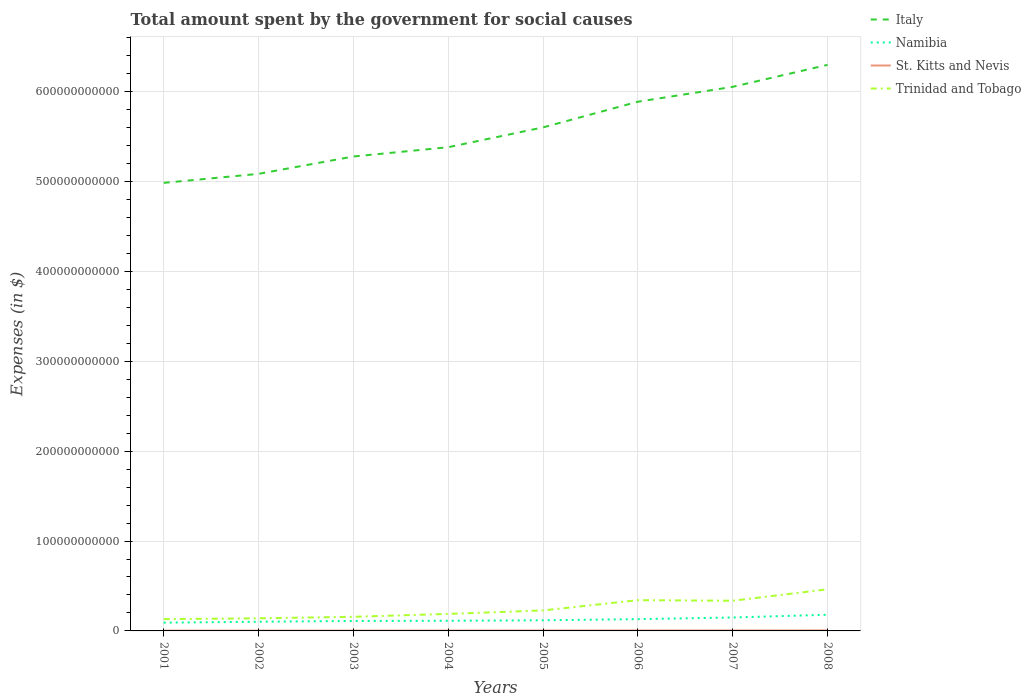How many different coloured lines are there?
Give a very brief answer. 4. Does the line corresponding to Trinidad and Tobago intersect with the line corresponding to St. Kitts and Nevis?
Provide a succinct answer. No. Across all years, what is the maximum amount spent for social causes by the government in St. Kitts and Nevis?
Keep it short and to the point. 3.07e+08. In which year was the amount spent for social causes by the government in Namibia maximum?
Make the answer very short. 2001. What is the total amount spent for social causes by the government in Trinidad and Tobago in the graph?
Offer a very short reply. -3.23e+1. What is the difference between the highest and the second highest amount spent for social causes by the government in St. Kitts and Nevis?
Ensure brevity in your answer.  2.29e+08. How many lines are there?
Your answer should be compact. 4. How many years are there in the graph?
Your response must be concise. 8. What is the difference between two consecutive major ticks on the Y-axis?
Offer a terse response. 1.00e+11. Does the graph contain any zero values?
Your response must be concise. No. What is the title of the graph?
Ensure brevity in your answer.  Total amount spent by the government for social causes. Does "Kiribati" appear as one of the legend labels in the graph?
Give a very brief answer. No. What is the label or title of the X-axis?
Your answer should be very brief. Years. What is the label or title of the Y-axis?
Make the answer very short. Expenses (in $). What is the Expenses (in $) of Italy in 2001?
Your answer should be compact. 4.99e+11. What is the Expenses (in $) of Namibia in 2001?
Your answer should be very brief. 9.20e+09. What is the Expenses (in $) of St. Kitts and Nevis in 2001?
Provide a short and direct response. 3.07e+08. What is the Expenses (in $) of Trinidad and Tobago in 2001?
Make the answer very short. 1.31e+1. What is the Expenses (in $) of Italy in 2002?
Your answer should be compact. 5.09e+11. What is the Expenses (in $) in Namibia in 2002?
Make the answer very short. 1.02e+1. What is the Expenses (in $) of St. Kitts and Nevis in 2002?
Provide a succinct answer. 3.24e+08. What is the Expenses (in $) in Trinidad and Tobago in 2002?
Give a very brief answer. 1.40e+1. What is the Expenses (in $) of Italy in 2003?
Make the answer very short. 5.28e+11. What is the Expenses (in $) of Namibia in 2003?
Offer a very short reply. 1.11e+1. What is the Expenses (in $) of St. Kitts and Nevis in 2003?
Provide a short and direct response. 3.33e+08. What is the Expenses (in $) in Trinidad and Tobago in 2003?
Offer a very short reply. 1.57e+1. What is the Expenses (in $) of Italy in 2004?
Your response must be concise. 5.38e+11. What is the Expenses (in $) in Namibia in 2004?
Keep it short and to the point. 1.13e+1. What is the Expenses (in $) of St. Kitts and Nevis in 2004?
Make the answer very short. 3.82e+08. What is the Expenses (in $) of Trinidad and Tobago in 2004?
Make the answer very short. 1.89e+1. What is the Expenses (in $) in Italy in 2005?
Give a very brief answer. 5.60e+11. What is the Expenses (in $) in Namibia in 2005?
Provide a short and direct response. 1.18e+1. What is the Expenses (in $) of St. Kitts and Nevis in 2005?
Ensure brevity in your answer.  4.40e+08. What is the Expenses (in $) of Trinidad and Tobago in 2005?
Your answer should be very brief. 2.28e+1. What is the Expenses (in $) in Italy in 2006?
Offer a very short reply. 5.89e+11. What is the Expenses (in $) of Namibia in 2006?
Ensure brevity in your answer.  1.31e+1. What is the Expenses (in $) in St. Kitts and Nevis in 2006?
Keep it short and to the point. 4.78e+08. What is the Expenses (in $) in Trinidad and Tobago in 2006?
Make the answer very short. 3.42e+1. What is the Expenses (in $) of Italy in 2007?
Ensure brevity in your answer.  6.05e+11. What is the Expenses (in $) of Namibia in 2007?
Your response must be concise. 1.49e+1. What is the Expenses (in $) of St. Kitts and Nevis in 2007?
Ensure brevity in your answer.  5.00e+08. What is the Expenses (in $) of Trinidad and Tobago in 2007?
Your answer should be very brief. 3.36e+1. What is the Expenses (in $) of Italy in 2008?
Offer a very short reply. 6.30e+11. What is the Expenses (in $) of Namibia in 2008?
Your answer should be compact. 1.80e+1. What is the Expenses (in $) of St. Kitts and Nevis in 2008?
Your answer should be compact. 5.36e+08. What is the Expenses (in $) in Trinidad and Tobago in 2008?
Your answer should be very brief. 4.63e+1. Across all years, what is the maximum Expenses (in $) of Italy?
Keep it short and to the point. 6.30e+11. Across all years, what is the maximum Expenses (in $) of Namibia?
Offer a terse response. 1.80e+1. Across all years, what is the maximum Expenses (in $) in St. Kitts and Nevis?
Offer a terse response. 5.36e+08. Across all years, what is the maximum Expenses (in $) of Trinidad and Tobago?
Keep it short and to the point. 4.63e+1. Across all years, what is the minimum Expenses (in $) in Italy?
Offer a terse response. 4.99e+11. Across all years, what is the minimum Expenses (in $) of Namibia?
Your response must be concise. 9.20e+09. Across all years, what is the minimum Expenses (in $) in St. Kitts and Nevis?
Offer a very short reply. 3.07e+08. Across all years, what is the minimum Expenses (in $) of Trinidad and Tobago?
Give a very brief answer. 1.31e+1. What is the total Expenses (in $) in Italy in the graph?
Ensure brevity in your answer.  4.46e+12. What is the total Expenses (in $) in Namibia in the graph?
Offer a terse response. 9.97e+1. What is the total Expenses (in $) in St. Kitts and Nevis in the graph?
Provide a short and direct response. 3.30e+09. What is the total Expenses (in $) of Trinidad and Tobago in the graph?
Provide a succinct answer. 1.99e+11. What is the difference between the Expenses (in $) in Italy in 2001 and that in 2002?
Make the answer very short. -1.00e+1. What is the difference between the Expenses (in $) of Namibia in 2001 and that in 2002?
Offer a terse response. -1.01e+09. What is the difference between the Expenses (in $) in St. Kitts and Nevis in 2001 and that in 2002?
Keep it short and to the point. -1.65e+07. What is the difference between the Expenses (in $) of Trinidad and Tobago in 2001 and that in 2002?
Offer a very short reply. -8.91e+08. What is the difference between the Expenses (in $) of Italy in 2001 and that in 2003?
Ensure brevity in your answer.  -2.93e+1. What is the difference between the Expenses (in $) in Namibia in 2001 and that in 2003?
Keep it short and to the point. -1.88e+09. What is the difference between the Expenses (in $) of St. Kitts and Nevis in 2001 and that in 2003?
Provide a succinct answer. -2.61e+07. What is the difference between the Expenses (in $) in Trinidad and Tobago in 2001 and that in 2003?
Your answer should be compact. -2.60e+09. What is the difference between the Expenses (in $) of Italy in 2001 and that in 2004?
Ensure brevity in your answer.  -3.97e+1. What is the difference between the Expenses (in $) of Namibia in 2001 and that in 2004?
Provide a short and direct response. -2.09e+09. What is the difference between the Expenses (in $) of St. Kitts and Nevis in 2001 and that in 2004?
Provide a succinct answer. -7.45e+07. What is the difference between the Expenses (in $) in Trinidad and Tobago in 2001 and that in 2004?
Provide a short and direct response. -5.80e+09. What is the difference between the Expenses (in $) of Italy in 2001 and that in 2005?
Your answer should be compact. -6.17e+1. What is the difference between the Expenses (in $) in Namibia in 2001 and that in 2005?
Your answer should be very brief. -2.64e+09. What is the difference between the Expenses (in $) in St. Kitts and Nevis in 2001 and that in 2005?
Your answer should be very brief. -1.33e+08. What is the difference between the Expenses (in $) in Trinidad and Tobago in 2001 and that in 2005?
Ensure brevity in your answer.  -9.68e+09. What is the difference between the Expenses (in $) in Italy in 2001 and that in 2006?
Your response must be concise. -9.03e+1. What is the difference between the Expenses (in $) of Namibia in 2001 and that in 2006?
Offer a very short reply. -3.91e+09. What is the difference between the Expenses (in $) in St. Kitts and Nevis in 2001 and that in 2006?
Offer a very short reply. -1.71e+08. What is the difference between the Expenses (in $) in Trinidad and Tobago in 2001 and that in 2006?
Offer a very short reply. -2.11e+1. What is the difference between the Expenses (in $) of Italy in 2001 and that in 2007?
Make the answer very short. -1.07e+11. What is the difference between the Expenses (in $) in Namibia in 2001 and that in 2007?
Offer a very short reply. -5.74e+09. What is the difference between the Expenses (in $) in St. Kitts and Nevis in 2001 and that in 2007?
Your answer should be very brief. -1.93e+08. What is the difference between the Expenses (in $) in Trinidad and Tobago in 2001 and that in 2007?
Provide a succinct answer. -2.04e+1. What is the difference between the Expenses (in $) in Italy in 2001 and that in 2008?
Your response must be concise. -1.31e+11. What is the difference between the Expenses (in $) in Namibia in 2001 and that in 2008?
Offer a very short reply. -8.82e+09. What is the difference between the Expenses (in $) of St. Kitts and Nevis in 2001 and that in 2008?
Offer a very short reply. -2.29e+08. What is the difference between the Expenses (in $) in Trinidad and Tobago in 2001 and that in 2008?
Your response must be concise. -3.32e+1. What is the difference between the Expenses (in $) in Italy in 2002 and that in 2003?
Offer a terse response. -1.93e+1. What is the difference between the Expenses (in $) in Namibia in 2002 and that in 2003?
Keep it short and to the point. -8.63e+08. What is the difference between the Expenses (in $) of St. Kitts and Nevis in 2002 and that in 2003?
Offer a very short reply. -9.60e+06. What is the difference between the Expenses (in $) in Trinidad and Tobago in 2002 and that in 2003?
Ensure brevity in your answer.  -1.71e+09. What is the difference between the Expenses (in $) in Italy in 2002 and that in 2004?
Your answer should be very brief. -2.96e+1. What is the difference between the Expenses (in $) in Namibia in 2002 and that in 2004?
Offer a very short reply. -1.07e+09. What is the difference between the Expenses (in $) of St. Kitts and Nevis in 2002 and that in 2004?
Offer a terse response. -5.80e+07. What is the difference between the Expenses (in $) of Trinidad and Tobago in 2002 and that in 2004?
Offer a very short reply. -4.90e+09. What is the difference between the Expenses (in $) of Italy in 2002 and that in 2005?
Keep it short and to the point. -5.17e+1. What is the difference between the Expenses (in $) in Namibia in 2002 and that in 2005?
Ensure brevity in your answer.  -1.62e+09. What is the difference between the Expenses (in $) in St. Kitts and Nevis in 2002 and that in 2005?
Ensure brevity in your answer.  -1.16e+08. What is the difference between the Expenses (in $) of Trinidad and Tobago in 2002 and that in 2005?
Offer a terse response. -8.79e+09. What is the difference between the Expenses (in $) in Italy in 2002 and that in 2006?
Your response must be concise. -8.03e+1. What is the difference between the Expenses (in $) of Namibia in 2002 and that in 2006?
Ensure brevity in your answer.  -2.90e+09. What is the difference between the Expenses (in $) of St. Kitts and Nevis in 2002 and that in 2006?
Your response must be concise. -1.55e+08. What is the difference between the Expenses (in $) of Trinidad and Tobago in 2002 and that in 2006?
Offer a terse response. -2.02e+1. What is the difference between the Expenses (in $) of Italy in 2002 and that in 2007?
Provide a short and direct response. -9.68e+1. What is the difference between the Expenses (in $) in Namibia in 2002 and that in 2007?
Provide a short and direct response. -4.73e+09. What is the difference between the Expenses (in $) of St. Kitts and Nevis in 2002 and that in 2007?
Offer a very short reply. -1.77e+08. What is the difference between the Expenses (in $) of Trinidad and Tobago in 2002 and that in 2007?
Ensure brevity in your answer.  -1.96e+1. What is the difference between the Expenses (in $) of Italy in 2002 and that in 2008?
Provide a succinct answer. -1.21e+11. What is the difference between the Expenses (in $) in Namibia in 2002 and that in 2008?
Offer a very short reply. -7.81e+09. What is the difference between the Expenses (in $) in St. Kitts and Nevis in 2002 and that in 2008?
Your answer should be compact. -2.13e+08. What is the difference between the Expenses (in $) in Trinidad and Tobago in 2002 and that in 2008?
Ensure brevity in your answer.  -3.23e+1. What is the difference between the Expenses (in $) of Italy in 2003 and that in 2004?
Make the answer very short. -1.03e+1. What is the difference between the Expenses (in $) in Namibia in 2003 and that in 2004?
Your answer should be very brief. -2.09e+08. What is the difference between the Expenses (in $) in St. Kitts and Nevis in 2003 and that in 2004?
Provide a succinct answer. -4.84e+07. What is the difference between the Expenses (in $) of Trinidad and Tobago in 2003 and that in 2004?
Your answer should be very brief. -3.19e+09. What is the difference between the Expenses (in $) of Italy in 2003 and that in 2005?
Keep it short and to the point. -3.24e+1. What is the difference between the Expenses (in $) in Namibia in 2003 and that in 2005?
Offer a terse response. -7.58e+08. What is the difference between the Expenses (in $) in St. Kitts and Nevis in 2003 and that in 2005?
Make the answer very short. -1.07e+08. What is the difference between the Expenses (in $) of Trinidad and Tobago in 2003 and that in 2005?
Keep it short and to the point. -7.08e+09. What is the difference between the Expenses (in $) of Italy in 2003 and that in 2006?
Give a very brief answer. -6.09e+1. What is the difference between the Expenses (in $) in Namibia in 2003 and that in 2006?
Provide a succinct answer. -2.03e+09. What is the difference between the Expenses (in $) in St. Kitts and Nevis in 2003 and that in 2006?
Your response must be concise. -1.45e+08. What is the difference between the Expenses (in $) in Trinidad and Tobago in 2003 and that in 2006?
Your answer should be compact. -1.85e+1. What is the difference between the Expenses (in $) of Italy in 2003 and that in 2007?
Provide a short and direct response. -7.75e+1. What is the difference between the Expenses (in $) of Namibia in 2003 and that in 2007?
Offer a very short reply. -3.86e+09. What is the difference between the Expenses (in $) of St. Kitts and Nevis in 2003 and that in 2007?
Provide a short and direct response. -1.67e+08. What is the difference between the Expenses (in $) of Trinidad and Tobago in 2003 and that in 2007?
Your response must be concise. -1.78e+1. What is the difference between the Expenses (in $) in Italy in 2003 and that in 2008?
Ensure brevity in your answer.  -1.02e+11. What is the difference between the Expenses (in $) in Namibia in 2003 and that in 2008?
Offer a very short reply. -6.94e+09. What is the difference between the Expenses (in $) in St. Kitts and Nevis in 2003 and that in 2008?
Keep it short and to the point. -2.03e+08. What is the difference between the Expenses (in $) of Trinidad and Tobago in 2003 and that in 2008?
Your response must be concise. -3.06e+1. What is the difference between the Expenses (in $) in Italy in 2004 and that in 2005?
Your response must be concise. -2.21e+1. What is the difference between the Expenses (in $) in Namibia in 2004 and that in 2005?
Offer a very short reply. -5.49e+08. What is the difference between the Expenses (in $) of St. Kitts and Nevis in 2004 and that in 2005?
Offer a very short reply. -5.83e+07. What is the difference between the Expenses (in $) of Trinidad and Tobago in 2004 and that in 2005?
Give a very brief answer. -3.89e+09. What is the difference between the Expenses (in $) of Italy in 2004 and that in 2006?
Keep it short and to the point. -5.06e+1. What is the difference between the Expenses (in $) in Namibia in 2004 and that in 2006?
Offer a terse response. -1.82e+09. What is the difference between the Expenses (in $) in St. Kitts and Nevis in 2004 and that in 2006?
Give a very brief answer. -9.67e+07. What is the difference between the Expenses (in $) of Trinidad and Tobago in 2004 and that in 2006?
Keep it short and to the point. -1.53e+1. What is the difference between the Expenses (in $) of Italy in 2004 and that in 2007?
Your response must be concise. -6.72e+1. What is the difference between the Expenses (in $) of Namibia in 2004 and that in 2007?
Provide a short and direct response. -3.65e+09. What is the difference between the Expenses (in $) in St. Kitts and Nevis in 2004 and that in 2007?
Make the answer very short. -1.19e+08. What is the difference between the Expenses (in $) in Trinidad and Tobago in 2004 and that in 2007?
Offer a very short reply. -1.46e+1. What is the difference between the Expenses (in $) of Italy in 2004 and that in 2008?
Your answer should be very brief. -9.16e+1. What is the difference between the Expenses (in $) in Namibia in 2004 and that in 2008?
Your answer should be very brief. -6.73e+09. What is the difference between the Expenses (in $) of St. Kitts and Nevis in 2004 and that in 2008?
Your answer should be very brief. -1.55e+08. What is the difference between the Expenses (in $) of Trinidad and Tobago in 2004 and that in 2008?
Your response must be concise. -2.74e+1. What is the difference between the Expenses (in $) in Italy in 2005 and that in 2006?
Keep it short and to the point. -2.86e+1. What is the difference between the Expenses (in $) in Namibia in 2005 and that in 2006?
Provide a short and direct response. -1.27e+09. What is the difference between the Expenses (in $) of St. Kitts and Nevis in 2005 and that in 2006?
Make the answer very short. -3.84e+07. What is the difference between the Expenses (in $) of Trinidad and Tobago in 2005 and that in 2006?
Make the answer very short. -1.14e+1. What is the difference between the Expenses (in $) in Italy in 2005 and that in 2007?
Your response must be concise. -4.51e+1. What is the difference between the Expenses (in $) in Namibia in 2005 and that in 2007?
Provide a succinct answer. -3.11e+09. What is the difference between the Expenses (in $) of St. Kitts and Nevis in 2005 and that in 2007?
Your answer should be compact. -6.03e+07. What is the difference between the Expenses (in $) of Trinidad and Tobago in 2005 and that in 2007?
Give a very brief answer. -1.08e+1. What is the difference between the Expenses (in $) in Italy in 2005 and that in 2008?
Offer a very short reply. -6.96e+1. What is the difference between the Expenses (in $) of Namibia in 2005 and that in 2008?
Give a very brief answer. -6.18e+09. What is the difference between the Expenses (in $) of St. Kitts and Nevis in 2005 and that in 2008?
Offer a very short reply. -9.64e+07. What is the difference between the Expenses (in $) of Trinidad and Tobago in 2005 and that in 2008?
Your answer should be very brief. -2.35e+1. What is the difference between the Expenses (in $) of Italy in 2006 and that in 2007?
Your response must be concise. -1.66e+1. What is the difference between the Expenses (in $) of Namibia in 2006 and that in 2007?
Offer a very short reply. -1.83e+09. What is the difference between the Expenses (in $) of St. Kitts and Nevis in 2006 and that in 2007?
Provide a succinct answer. -2.19e+07. What is the difference between the Expenses (in $) in Trinidad and Tobago in 2006 and that in 2007?
Offer a very short reply. 6.42e+08. What is the difference between the Expenses (in $) in Italy in 2006 and that in 2008?
Provide a short and direct response. -4.10e+1. What is the difference between the Expenses (in $) of Namibia in 2006 and that in 2008?
Provide a succinct answer. -4.91e+09. What is the difference between the Expenses (in $) of St. Kitts and Nevis in 2006 and that in 2008?
Ensure brevity in your answer.  -5.80e+07. What is the difference between the Expenses (in $) of Trinidad and Tobago in 2006 and that in 2008?
Keep it short and to the point. -1.21e+1. What is the difference between the Expenses (in $) of Italy in 2007 and that in 2008?
Provide a short and direct response. -2.44e+1. What is the difference between the Expenses (in $) in Namibia in 2007 and that in 2008?
Keep it short and to the point. -3.08e+09. What is the difference between the Expenses (in $) in St. Kitts and Nevis in 2007 and that in 2008?
Offer a terse response. -3.61e+07. What is the difference between the Expenses (in $) of Trinidad and Tobago in 2007 and that in 2008?
Offer a terse response. -1.28e+1. What is the difference between the Expenses (in $) in Italy in 2001 and the Expenses (in $) in Namibia in 2002?
Provide a short and direct response. 4.88e+11. What is the difference between the Expenses (in $) of Italy in 2001 and the Expenses (in $) of St. Kitts and Nevis in 2002?
Give a very brief answer. 4.98e+11. What is the difference between the Expenses (in $) in Italy in 2001 and the Expenses (in $) in Trinidad and Tobago in 2002?
Ensure brevity in your answer.  4.84e+11. What is the difference between the Expenses (in $) in Namibia in 2001 and the Expenses (in $) in St. Kitts and Nevis in 2002?
Make the answer very short. 8.88e+09. What is the difference between the Expenses (in $) in Namibia in 2001 and the Expenses (in $) in Trinidad and Tobago in 2002?
Keep it short and to the point. -4.82e+09. What is the difference between the Expenses (in $) in St. Kitts and Nevis in 2001 and the Expenses (in $) in Trinidad and Tobago in 2002?
Your response must be concise. -1.37e+1. What is the difference between the Expenses (in $) of Italy in 2001 and the Expenses (in $) of Namibia in 2003?
Give a very brief answer. 4.87e+11. What is the difference between the Expenses (in $) in Italy in 2001 and the Expenses (in $) in St. Kitts and Nevis in 2003?
Ensure brevity in your answer.  4.98e+11. What is the difference between the Expenses (in $) of Italy in 2001 and the Expenses (in $) of Trinidad and Tobago in 2003?
Make the answer very short. 4.83e+11. What is the difference between the Expenses (in $) in Namibia in 2001 and the Expenses (in $) in St. Kitts and Nevis in 2003?
Offer a very short reply. 8.87e+09. What is the difference between the Expenses (in $) of Namibia in 2001 and the Expenses (in $) of Trinidad and Tobago in 2003?
Make the answer very short. -6.53e+09. What is the difference between the Expenses (in $) of St. Kitts and Nevis in 2001 and the Expenses (in $) of Trinidad and Tobago in 2003?
Offer a very short reply. -1.54e+1. What is the difference between the Expenses (in $) of Italy in 2001 and the Expenses (in $) of Namibia in 2004?
Your answer should be very brief. 4.87e+11. What is the difference between the Expenses (in $) in Italy in 2001 and the Expenses (in $) in St. Kitts and Nevis in 2004?
Provide a succinct answer. 4.98e+11. What is the difference between the Expenses (in $) in Italy in 2001 and the Expenses (in $) in Trinidad and Tobago in 2004?
Your answer should be very brief. 4.80e+11. What is the difference between the Expenses (in $) in Namibia in 2001 and the Expenses (in $) in St. Kitts and Nevis in 2004?
Offer a very short reply. 8.82e+09. What is the difference between the Expenses (in $) in Namibia in 2001 and the Expenses (in $) in Trinidad and Tobago in 2004?
Your response must be concise. -9.72e+09. What is the difference between the Expenses (in $) of St. Kitts and Nevis in 2001 and the Expenses (in $) of Trinidad and Tobago in 2004?
Your response must be concise. -1.86e+1. What is the difference between the Expenses (in $) in Italy in 2001 and the Expenses (in $) in Namibia in 2005?
Your answer should be compact. 4.87e+11. What is the difference between the Expenses (in $) of Italy in 2001 and the Expenses (in $) of St. Kitts and Nevis in 2005?
Give a very brief answer. 4.98e+11. What is the difference between the Expenses (in $) of Italy in 2001 and the Expenses (in $) of Trinidad and Tobago in 2005?
Your answer should be very brief. 4.76e+11. What is the difference between the Expenses (in $) in Namibia in 2001 and the Expenses (in $) in St. Kitts and Nevis in 2005?
Offer a terse response. 8.76e+09. What is the difference between the Expenses (in $) in Namibia in 2001 and the Expenses (in $) in Trinidad and Tobago in 2005?
Make the answer very short. -1.36e+1. What is the difference between the Expenses (in $) of St. Kitts and Nevis in 2001 and the Expenses (in $) of Trinidad and Tobago in 2005?
Provide a succinct answer. -2.25e+1. What is the difference between the Expenses (in $) in Italy in 2001 and the Expenses (in $) in Namibia in 2006?
Provide a short and direct response. 4.85e+11. What is the difference between the Expenses (in $) in Italy in 2001 and the Expenses (in $) in St. Kitts and Nevis in 2006?
Ensure brevity in your answer.  4.98e+11. What is the difference between the Expenses (in $) of Italy in 2001 and the Expenses (in $) of Trinidad and Tobago in 2006?
Offer a very short reply. 4.64e+11. What is the difference between the Expenses (in $) in Namibia in 2001 and the Expenses (in $) in St. Kitts and Nevis in 2006?
Offer a very short reply. 8.72e+09. What is the difference between the Expenses (in $) of Namibia in 2001 and the Expenses (in $) of Trinidad and Tobago in 2006?
Give a very brief answer. -2.50e+1. What is the difference between the Expenses (in $) in St. Kitts and Nevis in 2001 and the Expenses (in $) in Trinidad and Tobago in 2006?
Offer a very short reply. -3.39e+1. What is the difference between the Expenses (in $) of Italy in 2001 and the Expenses (in $) of Namibia in 2007?
Your response must be concise. 4.84e+11. What is the difference between the Expenses (in $) in Italy in 2001 and the Expenses (in $) in St. Kitts and Nevis in 2007?
Ensure brevity in your answer.  4.98e+11. What is the difference between the Expenses (in $) of Italy in 2001 and the Expenses (in $) of Trinidad and Tobago in 2007?
Your answer should be very brief. 4.65e+11. What is the difference between the Expenses (in $) in Namibia in 2001 and the Expenses (in $) in St. Kitts and Nevis in 2007?
Give a very brief answer. 8.70e+09. What is the difference between the Expenses (in $) of Namibia in 2001 and the Expenses (in $) of Trinidad and Tobago in 2007?
Offer a terse response. -2.44e+1. What is the difference between the Expenses (in $) in St. Kitts and Nevis in 2001 and the Expenses (in $) in Trinidad and Tobago in 2007?
Provide a succinct answer. -3.33e+1. What is the difference between the Expenses (in $) of Italy in 2001 and the Expenses (in $) of Namibia in 2008?
Provide a short and direct response. 4.80e+11. What is the difference between the Expenses (in $) in Italy in 2001 and the Expenses (in $) in St. Kitts and Nevis in 2008?
Offer a terse response. 4.98e+11. What is the difference between the Expenses (in $) in Italy in 2001 and the Expenses (in $) in Trinidad and Tobago in 2008?
Keep it short and to the point. 4.52e+11. What is the difference between the Expenses (in $) in Namibia in 2001 and the Expenses (in $) in St. Kitts and Nevis in 2008?
Your response must be concise. 8.66e+09. What is the difference between the Expenses (in $) in Namibia in 2001 and the Expenses (in $) in Trinidad and Tobago in 2008?
Your response must be concise. -3.71e+1. What is the difference between the Expenses (in $) in St. Kitts and Nevis in 2001 and the Expenses (in $) in Trinidad and Tobago in 2008?
Ensure brevity in your answer.  -4.60e+1. What is the difference between the Expenses (in $) of Italy in 2002 and the Expenses (in $) of Namibia in 2003?
Offer a terse response. 4.97e+11. What is the difference between the Expenses (in $) in Italy in 2002 and the Expenses (in $) in St. Kitts and Nevis in 2003?
Ensure brevity in your answer.  5.08e+11. What is the difference between the Expenses (in $) in Italy in 2002 and the Expenses (in $) in Trinidad and Tobago in 2003?
Provide a short and direct response. 4.93e+11. What is the difference between the Expenses (in $) of Namibia in 2002 and the Expenses (in $) of St. Kitts and Nevis in 2003?
Your response must be concise. 9.88e+09. What is the difference between the Expenses (in $) in Namibia in 2002 and the Expenses (in $) in Trinidad and Tobago in 2003?
Provide a short and direct response. -5.51e+09. What is the difference between the Expenses (in $) of St. Kitts and Nevis in 2002 and the Expenses (in $) of Trinidad and Tobago in 2003?
Your response must be concise. -1.54e+1. What is the difference between the Expenses (in $) in Italy in 2002 and the Expenses (in $) in Namibia in 2004?
Keep it short and to the point. 4.97e+11. What is the difference between the Expenses (in $) in Italy in 2002 and the Expenses (in $) in St. Kitts and Nevis in 2004?
Offer a terse response. 5.08e+11. What is the difference between the Expenses (in $) of Italy in 2002 and the Expenses (in $) of Trinidad and Tobago in 2004?
Provide a succinct answer. 4.90e+11. What is the difference between the Expenses (in $) of Namibia in 2002 and the Expenses (in $) of St. Kitts and Nevis in 2004?
Provide a short and direct response. 9.83e+09. What is the difference between the Expenses (in $) in Namibia in 2002 and the Expenses (in $) in Trinidad and Tobago in 2004?
Ensure brevity in your answer.  -8.71e+09. What is the difference between the Expenses (in $) of St. Kitts and Nevis in 2002 and the Expenses (in $) of Trinidad and Tobago in 2004?
Your response must be concise. -1.86e+1. What is the difference between the Expenses (in $) of Italy in 2002 and the Expenses (in $) of Namibia in 2005?
Make the answer very short. 4.97e+11. What is the difference between the Expenses (in $) in Italy in 2002 and the Expenses (in $) in St. Kitts and Nevis in 2005?
Give a very brief answer. 5.08e+11. What is the difference between the Expenses (in $) in Italy in 2002 and the Expenses (in $) in Trinidad and Tobago in 2005?
Make the answer very short. 4.86e+11. What is the difference between the Expenses (in $) of Namibia in 2002 and the Expenses (in $) of St. Kitts and Nevis in 2005?
Offer a terse response. 9.78e+09. What is the difference between the Expenses (in $) of Namibia in 2002 and the Expenses (in $) of Trinidad and Tobago in 2005?
Provide a short and direct response. -1.26e+1. What is the difference between the Expenses (in $) in St. Kitts and Nevis in 2002 and the Expenses (in $) in Trinidad and Tobago in 2005?
Provide a succinct answer. -2.25e+1. What is the difference between the Expenses (in $) of Italy in 2002 and the Expenses (in $) of Namibia in 2006?
Offer a very short reply. 4.95e+11. What is the difference between the Expenses (in $) of Italy in 2002 and the Expenses (in $) of St. Kitts and Nevis in 2006?
Ensure brevity in your answer.  5.08e+11. What is the difference between the Expenses (in $) in Italy in 2002 and the Expenses (in $) in Trinidad and Tobago in 2006?
Offer a very short reply. 4.74e+11. What is the difference between the Expenses (in $) in Namibia in 2002 and the Expenses (in $) in St. Kitts and Nevis in 2006?
Keep it short and to the point. 9.74e+09. What is the difference between the Expenses (in $) of Namibia in 2002 and the Expenses (in $) of Trinidad and Tobago in 2006?
Offer a terse response. -2.40e+1. What is the difference between the Expenses (in $) in St. Kitts and Nevis in 2002 and the Expenses (in $) in Trinidad and Tobago in 2006?
Offer a very short reply. -3.39e+1. What is the difference between the Expenses (in $) of Italy in 2002 and the Expenses (in $) of Namibia in 2007?
Provide a succinct answer. 4.94e+11. What is the difference between the Expenses (in $) of Italy in 2002 and the Expenses (in $) of St. Kitts and Nevis in 2007?
Offer a terse response. 5.08e+11. What is the difference between the Expenses (in $) of Italy in 2002 and the Expenses (in $) of Trinidad and Tobago in 2007?
Ensure brevity in your answer.  4.75e+11. What is the difference between the Expenses (in $) in Namibia in 2002 and the Expenses (in $) in St. Kitts and Nevis in 2007?
Offer a terse response. 9.71e+09. What is the difference between the Expenses (in $) in Namibia in 2002 and the Expenses (in $) in Trinidad and Tobago in 2007?
Offer a terse response. -2.34e+1. What is the difference between the Expenses (in $) in St. Kitts and Nevis in 2002 and the Expenses (in $) in Trinidad and Tobago in 2007?
Keep it short and to the point. -3.32e+1. What is the difference between the Expenses (in $) of Italy in 2002 and the Expenses (in $) of Namibia in 2008?
Offer a very short reply. 4.91e+11. What is the difference between the Expenses (in $) in Italy in 2002 and the Expenses (in $) in St. Kitts and Nevis in 2008?
Offer a terse response. 5.08e+11. What is the difference between the Expenses (in $) in Italy in 2002 and the Expenses (in $) in Trinidad and Tobago in 2008?
Ensure brevity in your answer.  4.62e+11. What is the difference between the Expenses (in $) in Namibia in 2002 and the Expenses (in $) in St. Kitts and Nevis in 2008?
Your answer should be compact. 9.68e+09. What is the difference between the Expenses (in $) of Namibia in 2002 and the Expenses (in $) of Trinidad and Tobago in 2008?
Your answer should be compact. -3.61e+1. What is the difference between the Expenses (in $) in St. Kitts and Nevis in 2002 and the Expenses (in $) in Trinidad and Tobago in 2008?
Your answer should be compact. -4.60e+1. What is the difference between the Expenses (in $) in Italy in 2003 and the Expenses (in $) in Namibia in 2004?
Provide a short and direct response. 5.17e+11. What is the difference between the Expenses (in $) in Italy in 2003 and the Expenses (in $) in St. Kitts and Nevis in 2004?
Your response must be concise. 5.27e+11. What is the difference between the Expenses (in $) of Italy in 2003 and the Expenses (in $) of Trinidad and Tobago in 2004?
Your response must be concise. 5.09e+11. What is the difference between the Expenses (in $) in Namibia in 2003 and the Expenses (in $) in St. Kitts and Nevis in 2004?
Keep it short and to the point. 1.07e+1. What is the difference between the Expenses (in $) of Namibia in 2003 and the Expenses (in $) of Trinidad and Tobago in 2004?
Your answer should be compact. -7.84e+09. What is the difference between the Expenses (in $) in St. Kitts and Nevis in 2003 and the Expenses (in $) in Trinidad and Tobago in 2004?
Your response must be concise. -1.86e+1. What is the difference between the Expenses (in $) of Italy in 2003 and the Expenses (in $) of Namibia in 2005?
Your answer should be very brief. 5.16e+11. What is the difference between the Expenses (in $) of Italy in 2003 and the Expenses (in $) of St. Kitts and Nevis in 2005?
Offer a terse response. 5.27e+11. What is the difference between the Expenses (in $) in Italy in 2003 and the Expenses (in $) in Trinidad and Tobago in 2005?
Provide a succinct answer. 5.05e+11. What is the difference between the Expenses (in $) of Namibia in 2003 and the Expenses (in $) of St. Kitts and Nevis in 2005?
Provide a short and direct response. 1.06e+1. What is the difference between the Expenses (in $) in Namibia in 2003 and the Expenses (in $) in Trinidad and Tobago in 2005?
Make the answer very short. -1.17e+1. What is the difference between the Expenses (in $) in St. Kitts and Nevis in 2003 and the Expenses (in $) in Trinidad and Tobago in 2005?
Provide a succinct answer. -2.25e+1. What is the difference between the Expenses (in $) of Italy in 2003 and the Expenses (in $) of Namibia in 2006?
Make the answer very short. 5.15e+11. What is the difference between the Expenses (in $) of Italy in 2003 and the Expenses (in $) of St. Kitts and Nevis in 2006?
Provide a short and direct response. 5.27e+11. What is the difference between the Expenses (in $) of Italy in 2003 and the Expenses (in $) of Trinidad and Tobago in 2006?
Offer a terse response. 4.94e+11. What is the difference between the Expenses (in $) in Namibia in 2003 and the Expenses (in $) in St. Kitts and Nevis in 2006?
Offer a terse response. 1.06e+1. What is the difference between the Expenses (in $) of Namibia in 2003 and the Expenses (in $) of Trinidad and Tobago in 2006?
Give a very brief answer. -2.31e+1. What is the difference between the Expenses (in $) in St. Kitts and Nevis in 2003 and the Expenses (in $) in Trinidad and Tobago in 2006?
Your response must be concise. -3.39e+1. What is the difference between the Expenses (in $) in Italy in 2003 and the Expenses (in $) in Namibia in 2007?
Your answer should be very brief. 5.13e+11. What is the difference between the Expenses (in $) in Italy in 2003 and the Expenses (in $) in St. Kitts and Nevis in 2007?
Offer a terse response. 5.27e+11. What is the difference between the Expenses (in $) of Italy in 2003 and the Expenses (in $) of Trinidad and Tobago in 2007?
Your answer should be very brief. 4.94e+11. What is the difference between the Expenses (in $) of Namibia in 2003 and the Expenses (in $) of St. Kitts and Nevis in 2007?
Your answer should be very brief. 1.06e+1. What is the difference between the Expenses (in $) in Namibia in 2003 and the Expenses (in $) in Trinidad and Tobago in 2007?
Your answer should be very brief. -2.25e+1. What is the difference between the Expenses (in $) of St. Kitts and Nevis in 2003 and the Expenses (in $) of Trinidad and Tobago in 2007?
Offer a terse response. -3.32e+1. What is the difference between the Expenses (in $) in Italy in 2003 and the Expenses (in $) in Namibia in 2008?
Give a very brief answer. 5.10e+11. What is the difference between the Expenses (in $) in Italy in 2003 and the Expenses (in $) in St. Kitts and Nevis in 2008?
Offer a terse response. 5.27e+11. What is the difference between the Expenses (in $) in Italy in 2003 and the Expenses (in $) in Trinidad and Tobago in 2008?
Offer a very short reply. 4.82e+11. What is the difference between the Expenses (in $) of Namibia in 2003 and the Expenses (in $) of St. Kitts and Nevis in 2008?
Make the answer very short. 1.05e+1. What is the difference between the Expenses (in $) of Namibia in 2003 and the Expenses (in $) of Trinidad and Tobago in 2008?
Your answer should be compact. -3.53e+1. What is the difference between the Expenses (in $) in St. Kitts and Nevis in 2003 and the Expenses (in $) in Trinidad and Tobago in 2008?
Provide a succinct answer. -4.60e+1. What is the difference between the Expenses (in $) in Italy in 2004 and the Expenses (in $) in Namibia in 2005?
Offer a very short reply. 5.26e+11. What is the difference between the Expenses (in $) of Italy in 2004 and the Expenses (in $) of St. Kitts and Nevis in 2005?
Your answer should be compact. 5.38e+11. What is the difference between the Expenses (in $) of Italy in 2004 and the Expenses (in $) of Trinidad and Tobago in 2005?
Your answer should be very brief. 5.15e+11. What is the difference between the Expenses (in $) in Namibia in 2004 and the Expenses (in $) in St. Kitts and Nevis in 2005?
Keep it short and to the point. 1.08e+1. What is the difference between the Expenses (in $) in Namibia in 2004 and the Expenses (in $) in Trinidad and Tobago in 2005?
Ensure brevity in your answer.  -1.15e+1. What is the difference between the Expenses (in $) in St. Kitts and Nevis in 2004 and the Expenses (in $) in Trinidad and Tobago in 2005?
Make the answer very short. -2.24e+1. What is the difference between the Expenses (in $) in Italy in 2004 and the Expenses (in $) in Namibia in 2006?
Provide a succinct answer. 5.25e+11. What is the difference between the Expenses (in $) of Italy in 2004 and the Expenses (in $) of St. Kitts and Nevis in 2006?
Give a very brief answer. 5.38e+11. What is the difference between the Expenses (in $) in Italy in 2004 and the Expenses (in $) in Trinidad and Tobago in 2006?
Ensure brevity in your answer.  5.04e+11. What is the difference between the Expenses (in $) in Namibia in 2004 and the Expenses (in $) in St. Kitts and Nevis in 2006?
Make the answer very short. 1.08e+1. What is the difference between the Expenses (in $) of Namibia in 2004 and the Expenses (in $) of Trinidad and Tobago in 2006?
Keep it short and to the point. -2.29e+1. What is the difference between the Expenses (in $) of St. Kitts and Nevis in 2004 and the Expenses (in $) of Trinidad and Tobago in 2006?
Keep it short and to the point. -3.38e+1. What is the difference between the Expenses (in $) in Italy in 2004 and the Expenses (in $) in Namibia in 2007?
Offer a very short reply. 5.23e+11. What is the difference between the Expenses (in $) in Italy in 2004 and the Expenses (in $) in St. Kitts and Nevis in 2007?
Give a very brief answer. 5.38e+11. What is the difference between the Expenses (in $) in Italy in 2004 and the Expenses (in $) in Trinidad and Tobago in 2007?
Ensure brevity in your answer.  5.05e+11. What is the difference between the Expenses (in $) of Namibia in 2004 and the Expenses (in $) of St. Kitts and Nevis in 2007?
Keep it short and to the point. 1.08e+1. What is the difference between the Expenses (in $) of Namibia in 2004 and the Expenses (in $) of Trinidad and Tobago in 2007?
Offer a very short reply. -2.23e+1. What is the difference between the Expenses (in $) in St. Kitts and Nevis in 2004 and the Expenses (in $) in Trinidad and Tobago in 2007?
Give a very brief answer. -3.32e+1. What is the difference between the Expenses (in $) in Italy in 2004 and the Expenses (in $) in Namibia in 2008?
Provide a short and direct response. 5.20e+11. What is the difference between the Expenses (in $) of Italy in 2004 and the Expenses (in $) of St. Kitts and Nevis in 2008?
Offer a terse response. 5.38e+11. What is the difference between the Expenses (in $) in Italy in 2004 and the Expenses (in $) in Trinidad and Tobago in 2008?
Your response must be concise. 4.92e+11. What is the difference between the Expenses (in $) of Namibia in 2004 and the Expenses (in $) of St. Kitts and Nevis in 2008?
Provide a short and direct response. 1.08e+1. What is the difference between the Expenses (in $) in Namibia in 2004 and the Expenses (in $) in Trinidad and Tobago in 2008?
Your answer should be very brief. -3.50e+1. What is the difference between the Expenses (in $) in St. Kitts and Nevis in 2004 and the Expenses (in $) in Trinidad and Tobago in 2008?
Give a very brief answer. -4.60e+1. What is the difference between the Expenses (in $) in Italy in 2005 and the Expenses (in $) in Namibia in 2006?
Your answer should be very brief. 5.47e+11. What is the difference between the Expenses (in $) of Italy in 2005 and the Expenses (in $) of St. Kitts and Nevis in 2006?
Your answer should be compact. 5.60e+11. What is the difference between the Expenses (in $) in Italy in 2005 and the Expenses (in $) in Trinidad and Tobago in 2006?
Provide a short and direct response. 5.26e+11. What is the difference between the Expenses (in $) in Namibia in 2005 and the Expenses (in $) in St. Kitts and Nevis in 2006?
Make the answer very short. 1.14e+1. What is the difference between the Expenses (in $) of Namibia in 2005 and the Expenses (in $) of Trinidad and Tobago in 2006?
Give a very brief answer. -2.24e+1. What is the difference between the Expenses (in $) in St. Kitts and Nevis in 2005 and the Expenses (in $) in Trinidad and Tobago in 2006?
Provide a succinct answer. -3.38e+1. What is the difference between the Expenses (in $) in Italy in 2005 and the Expenses (in $) in Namibia in 2007?
Keep it short and to the point. 5.45e+11. What is the difference between the Expenses (in $) in Italy in 2005 and the Expenses (in $) in St. Kitts and Nevis in 2007?
Offer a terse response. 5.60e+11. What is the difference between the Expenses (in $) in Italy in 2005 and the Expenses (in $) in Trinidad and Tobago in 2007?
Provide a succinct answer. 5.27e+11. What is the difference between the Expenses (in $) of Namibia in 2005 and the Expenses (in $) of St. Kitts and Nevis in 2007?
Provide a succinct answer. 1.13e+1. What is the difference between the Expenses (in $) of Namibia in 2005 and the Expenses (in $) of Trinidad and Tobago in 2007?
Ensure brevity in your answer.  -2.17e+1. What is the difference between the Expenses (in $) in St. Kitts and Nevis in 2005 and the Expenses (in $) in Trinidad and Tobago in 2007?
Make the answer very short. -3.31e+1. What is the difference between the Expenses (in $) of Italy in 2005 and the Expenses (in $) of Namibia in 2008?
Provide a short and direct response. 5.42e+11. What is the difference between the Expenses (in $) in Italy in 2005 and the Expenses (in $) in St. Kitts and Nevis in 2008?
Your response must be concise. 5.60e+11. What is the difference between the Expenses (in $) in Italy in 2005 and the Expenses (in $) in Trinidad and Tobago in 2008?
Provide a succinct answer. 5.14e+11. What is the difference between the Expenses (in $) in Namibia in 2005 and the Expenses (in $) in St. Kitts and Nevis in 2008?
Offer a very short reply. 1.13e+1. What is the difference between the Expenses (in $) in Namibia in 2005 and the Expenses (in $) in Trinidad and Tobago in 2008?
Keep it short and to the point. -3.45e+1. What is the difference between the Expenses (in $) in St. Kitts and Nevis in 2005 and the Expenses (in $) in Trinidad and Tobago in 2008?
Your answer should be very brief. -4.59e+1. What is the difference between the Expenses (in $) of Italy in 2006 and the Expenses (in $) of Namibia in 2007?
Your response must be concise. 5.74e+11. What is the difference between the Expenses (in $) in Italy in 2006 and the Expenses (in $) in St. Kitts and Nevis in 2007?
Ensure brevity in your answer.  5.88e+11. What is the difference between the Expenses (in $) of Italy in 2006 and the Expenses (in $) of Trinidad and Tobago in 2007?
Offer a very short reply. 5.55e+11. What is the difference between the Expenses (in $) in Namibia in 2006 and the Expenses (in $) in St. Kitts and Nevis in 2007?
Keep it short and to the point. 1.26e+1. What is the difference between the Expenses (in $) of Namibia in 2006 and the Expenses (in $) of Trinidad and Tobago in 2007?
Your answer should be compact. -2.05e+1. What is the difference between the Expenses (in $) of St. Kitts and Nevis in 2006 and the Expenses (in $) of Trinidad and Tobago in 2007?
Keep it short and to the point. -3.31e+1. What is the difference between the Expenses (in $) of Italy in 2006 and the Expenses (in $) of Namibia in 2008?
Offer a very short reply. 5.71e+11. What is the difference between the Expenses (in $) in Italy in 2006 and the Expenses (in $) in St. Kitts and Nevis in 2008?
Ensure brevity in your answer.  5.88e+11. What is the difference between the Expenses (in $) in Italy in 2006 and the Expenses (in $) in Trinidad and Tobago in 2008?
Your answer should be compact. 5.42e+11. What is the difference between the Expenses (in $) in Namibia in 2006 and the Expenses (in $) in St. Kitts and Nevis in 2008?
Offer a very short reply. 1.26e+1. What is the difference between the Expenses (in $) of Namibia in 2006 and the Expenses (in $) of Trinidad and Tobago in 2008?
Provide a short and direct response. -3.32e+1. What is the difference between the Expenses (in $) of St. Kitts and Nevis in 2006 and the Expenses (in $) of Trinidad and Tobago in 2008?
Your answer should be compact. -4.59e+1. What is the difference between the Expenses (in $) of Italy in 2007 and the Expenses (in $) of Namibia in 2008?
Offer a very short reply. 5.87e+11. What is the difference between the Expenses (in $) in Italy in 2007 and the Expenses (in $) in St. Kitts and Nevis in 2008?
Keep it short and to the point. 6.05e+11. What is the difference between the Expenses (in $) of Italy in 2007 and the Expenses (in $) of Trinidad and Tobago in 2008?
Make the answer very short. 5.59e+11. What is the difference between the Expenses (in $) of Namibia in 2007 and the Expenses (in $) of St. Kitts and Nevis in 2008?
Offer a very short reply. 1.44e+1. What is the difference between the Expenses (in $) in Namibia in 2007 and the Expenses (in $) in Trinidad and Tobago in 2008?
Give a very brief answer. -3.14e+1. What is the difference between the Expenses (in $) in St. Kitts and Nevis in 2007 and the Expenses (in $) in Trinidad and Tobago in 2008?
Make the answer very short. -4.58e+1. What is the average Expenses (in $) in Italy per year?
Make the answer very short. 5.57e+11. What is the average Expenses (in $) in Namibia per year?
Offer a very short reply. 1.25e+1. What is the average Expenses (in $) of St. Kitts and Nevis per year?
Your answer should be very brief. 4.12e+08. What is the average Expenses (in $) of Trinidad and Tobago per year?
Keep it short and to the point. 2.48e+1. In the year 2001, what is the difference between the Expenses (in $) in Italy and Expenses (in $) in Namibia?
Offer a very short reply. 4.89e+11. In the year 2001, what is the difference between the Expenses (in $) of Italy and Expenses (in $) of St. Kitts and Nevis?
Provide a short and direct response. 4.98e+11. In the year 2001, what is the difference between the Expenses (in $) of Italy and Expenses (in $) of Trinidad and Tobago?
Give a very brief answer. 4.85e+11. In the year 2001, what is the difference between the Expenses (in $) in Namibia and Expenses (in $) in St. Kitts and Nevis?
Offer a very short reply. 8.89e+09. In the year 2001, what is the difference between the Expenses (in $) in Namibia and Expenses (in $) in Trinidad and Tobago?
Keep it short and to the point. -3.93e+09. In the year 2001, what is the difference between the Expenses (in $) in St. Kitts and Nevis and Expenses (in $) in Trinidad and Tobago?
Offer a very short reply. -1.28e+1. In the year 2002, what is the difference between the Expenses (in $) of Italy and Expenses (in $) of Namibia?
Ensure brevity in your answer.  4.98e+11. In the year 2002, what is the difference between the Expenses (in $) in Italy and Expenses (in $) in St. Kitts and Nevis?
Your answer should be compact. 5.08e+11. In the year 2002, what is the difference between the Expenses (in $) in Italy and Expenses (in $) in Trinidad and Tobago?
Keep it short and to the point. 4.95e+11. In the year 2002, what is the difference between the Expenses (in $) in Namibia and Expenses (in $) in St. Kitts and Nevis?
Provide a short and direct response. 9.89e+09. In the year 2002, what is the difference between the Expenses (in $) of Namibia and Expenses (in $) of Trinidad and Tobago?
Your answer should be compact. -3.80e+09. In the year 2002, what is the difference between the Expenses (in $) of St. Kitts and Nevis and Expenses (in $) of Trinidad and Tobago?
Your answer should be very brief. -1.37e+1. In the year 2003, what is the difference between the Expenses (in $) of Italy and Expenses (in $) of Namibia?
Offer a very short reply. 5.17e+11. In the year 2003, what is the difference between the Expenses (in $) of Italy and Expenses (in $) of St. Kitts and Nevis?
Your response must be concise. 5.28e+11. In the year 2003, what is the difference between the Expenses (in $) in Italy and Expenses (in $) in Trinidad and Tobago?
Keep it short and to the point. 5.12e+11. In the year 2003, what is the difference between the Expenses (in $) of Namibia and Expenses (in $) of St. Kitts and Nevis?
Offer a very short reply. 1.07e+1. In the year 2003, what is the difference between the Expenses (in $) in Namibia and Expenses (in $) in Trinidad and Tobago?
Keep it short and to the point. -4.65e+09. In the year 2003, what is the difference between the Expenses (in $) in St. Kitts and Nevis and Expenses (in $) in Trinidad and Tobago?
Keep it short and to the point. -1.54e+1. In the year 2004, what is the difference between the Expenses (in $) of Italy and Expenses (in $) of Namibia?
Your answer should be very brief. 5.27e+11. In the year 2004, what is the difference between the Expenses (in $) in Italy and Expenses (in $) in St. Kitts and Nevis?
Your answer should be compact. 5.38e+11. In the year 2004, what is the difference between the Expenses (in $) of Italy and Expenses (in $) of Trinidad and Tobago?
Your answer should be compact. 5.19e+11. In the year 2004, what is the difference between the Expenses (in $) in Namibia and Expenses (in $) in St. Kitts and Nevis?
Your answer should be very brief. 1.09e+1. In the year 2004, what is the difference between the Expenses (in $) in Namibia and Expenses (in $) in Trinidad and Tobago?
Make the answer very short. -7.63e+09. In the year 2004, what is the difference between the Expenses (in $) of St. Kitts and Nevis and Expenses (in $) of Trinidad and Tobago?
Provide a short and direct response. -1.85e+1. In the year 2005, what is the difference between the Expenses (in $) in Italy and Expenses (in $) in Namibia?
Keep it short and to the point. 5.48e+11. In the year 2005, what is the difference between the Expenses (in $) of Italy and Expenses (in $) of St. Kitts and Nevis?
Provide a succinct answer. 5.60e+11. In the year 2005, what is the difference between the Expenses (in $) of Italy and Expenses (in $) of Trinidad and Tobago?
Make the answer very short. 5.37e+11. In the year 2005, what is the difference between the Expenses (in $) in Namibia and Expenses (in $) in St. Kitts and Nevis?
Make the answer very short. 1.14e+1. In the year 2005, what is the difference between the Expenses (in $) in Namibia and Expenses (in $) in Trinidad and Tobago?
Provide a succinct answer. -1.10e+1. In the year 2005, what is the difference between the Expenses (in $) of St. Kitts and Nevis and Expenses (in $) of Trinidad and Tobago?
Ensure brevity in your answer.  -2.24e+1. In the year 2006, what is the difference between the Expenses (in $) of Italy and Expenses (in $) of Namibia?
Provide a short and direct response. 5.76e+11. In the year 2006, what is the difference between the Expenses (in $) of Italy and Expenses (in $) of St. Kitts and Nevis?
Provide a succinct answer. 5.88e+11. In the year 2006, what is the difference between the Expenses (in $) of Italy and Expenses (in $) of Trinidad and Tobago?
Provide a short and direct response. 5.55e+11. In the year 2006, what is the difference between the Expenses (in $) in Namibia and Expenses (in $) in St. Kitts and Nevis?
Your answer should be compact. 1.26e+1. In the year 2006, what is the difference between the Expenses (in $) of Namibia and Expenses (in $) of Trinidad and Tobago?
Ensure brevity in your answer.  -2.11e+1. In the year 2006, what is the difference between the Expenses (in $) in St. Kitts and Nevis and Expenses (in $) in Trinidad and Tobago?
Keep it short and to the point. -3.37e+1. In the year 2007, what is the difference between the Expenses (in $) in Italy and Expenses (in $) in Namibia?
Keep it short and to the point. 5.90e+11. In the year 2007, what is the difference between the Expenses (in $) in Italy and Expenses (in $) in St. Kitts and Nevis?
Your answer should be very brief. 6.05e+11. In the year 2007, what is the difference between the Expenses (in $) in Italy and Expenses (in $) in Trinidad and Tobago?
Your answer should be compact. 5.72e+11. In the year 2007, what is the difference between the Expenses (in $) of Namibia and Expenses (in $) of St. Kitts and Nevis?
Keep it short and to the point. 1.44e+1. In the year 2007, what is the difference between the Expenses (in $) in Namibia and Expenses (in $) in Trinidad and Tobago?
Your answer should be compact. -1.86e+1. In the year 2007, what is the difference between the Expenses (in $) in St. Kitts and Nevis and Expenses (in $) in Trinidad and Tobago?
Provide a succinct answer. -3.31e+1. In the year 2008, what is the difference between the Expenses (in $) of Italy and Expenses (in $) of Namibia?
Ensure brevity in your answer.  6.12e+11. In the year 2008, what is the difference between the Expenses (in $) of Italy and Expenses (in $) of St. Kitts and Nevis?
Your response must be concise. 6.29e+11. In the year 2008, what is the difference between the Expenses (in $) of Italy and Expenses (in $) of Trinidad and Tobago?
Offer a terse response. 5.83e+11. In the year 2008, what is the difference between the Expenses (in $) in Namibia and Expenses (in $) in St. Kitts and Nevis?
Give a very brief answer. 1.75e+1. In the year 2008, what is the difference between the Expenses (in $) of Namibia and Expenses (in $) of Trinidad and Tobago?
Provide a short and direct response. -2.83e+1. In the year 2008, what is the difference between the Expenses (in $) in St. Kitts and Nevis and Expenses (in $) in Trinidad and Tobago?
Keep it short and to the point. -4.58e+1. What is the ratio of the Expenses (in $) in Italy in 2001 to that in 2002?
Offer a very short reply. 0.98. What is the ratio of the Expenses (in $) of Namibia in 2001 to that in 2002?
Make the answer very short. 0.9. What is the ratio of the Expenses (in $) of St. Kitts and Nevis in 2001 to that in 2002?
Your response must be concise. 0.95. What is the ratio of the Expenses (in $) in Trinidad and Tobago in 2001 to that in 2002?
Offer a terse response. 0.94. What is the ratio of the Expenses (in $) in Namibia in 2001 to that in 2003?
Offer a terse response. 0.83. What is the ratio of the Expenses (in $) in St. Kitts and Nevis in 2001 to that in 2003?
Provide a short and direct response. 0.92. What is the ratio of the Expenses (in $) of Trinidad and Tobago in 2001 to that in 2003?
Offer a very short reply. 0.83. What is the ratio of the Expenses (in $) of Italy in 2001 to that in 2004?
Your response must be concise. 0.93. What is the ratio of the Expenses (in $) of Namibia in 2001 to that in 2004?
Offer a terse response. 0.82. What is the ratio of the Expenses (in $) in St. Kitts and Nevis in 2001 to that in 2004?
Make the answer very short. 0.8. What is the ratio of the Expenses (in $) in Trinidad and Tobago in 2001 to that in 2004?
Your answer should be very brief. 0.69. What is the ratio of the Expenses (in $) in Italy in 2001 to that in 2005?
Your answer should be compact. 0.89. What is the ratio of the Expenses (in $) in Namibia in 2001 to that in 2005?
Give a very brief answer. 0.78. What is the ratio of the Expenses (in $) in St. Kitts and Nevis in 2001 to that in 2005?
Make the answer very short. 0.7. What is the ratio of the Expenses (in $) in Trinidad and Tobago in 2001 to that in 2005?
Provide a succinct answer. 0.58. What is the ratio of the Expenses (in $) in Italy in 2001 to that in 2006?
Offer a very short reply. 0.85. What is the ratio of the Expenses (in $) of Namibia in 2001 to that in 2006?
Offer a very short reply. 0.7. What is the ratio of the Expenses (in $) of St. Kitts and Nevis in 2001 to that in 2006?
Ensure brevity in your answer.  0.64. What is the ratio of the Expenses (in $) of Trinidad and Tobago in 2001 to that in 2006?
Offer a terse response. 0.38. What is the ratio of the Expenses (in $) of Italy in 2001 to that in 2007?
Provide a short and direct response. 0.82. What is the ratio of the Expenses (in $) in Namibia in 2001 to that in 2007?
Your response must be concise. 0.62. What is the ratio of the Expenses (in $) of St. Kitts and Nevis in 2001 to that in 2007?
Offer a terse response. 0.61. What is the ratio of the Expenses (in $) in Trinidad and Tobago in 2001 to that in 2007?
Make the answer very short. 0.39. What is the ratio of the Expenses (in $) in Italy in 2001 to that in 2008?
Your answer should be compact. 0.79. What is the ratio of the Expenses (in $) in Namibia in 2001 to that in 2008?
Your answer should be compact. 0.51. What is the ratio of the Expenses (in $) of St. Kitts and Nevis in 2001 to that in 2008?
Make the answer very short. 0.57. What is the ratio of the Expenses (in $) in Trinidad and Tobago in 2001 to that in 2008?
Give a very brief answer. 0.28. What is the ratio of the Expenses (in $) in Italy in 2002 to that in 2003?
Ensure brevity in your answer.  0.96. What is the ratio of the Expenses (in $) of Namibia in 2002 to that in 2003?
Keep it short and to the point. 0.92. What is the ratio of the Expenses (in $) of St. Kitts and Nevis in 2002 to that in 2003?
Give a very brief answer. 0.97. What is the ratio of the Expenses (in $) in Trinidad and Tobago in 2002 to that in 2003?
Give a very brief answer. 0.89. What is the ratio of the Expenses (in $) of Italy in 2002 to that in 2004?
Keep it short and to the point. 0.94. What is the ratio of the Expenses (in $) in Namibia in 2002 to that in 2004?
Your answer should be compact. 0.91. What is the ratio of the Expenses (in $) of St. Kitts and Nevis in 2002 to that in 2004?
Your answer should be very brief. 0.85. What is the ratio of the Expenses (in $) in Trinidad and Tobago in 2002 to that in 2004?
Your answer should be very brief. 0.74. What is the ratio of the Expenses (in $) of Italy in 2002 to that in 2005?
Ensure brevity in your answer.  0.91. What is the ratio of the Expenses (in $) of Namibia in 2002 to that in 2005?
Keep it short and to the point. 0.86. What is the ratio of the Expenses (in $) in St. Kitts and Nevis in 2002 to that in 2005?
Offer a terse response. 0.74. What is the ratio of the Expenses (in $) in Trinidad and Tobago in 2002 to that in 2005?
Provide a succinct answer. 0.61. What is the ratio of the Expenses (in $) in Italy in 2002 to that in 2006?
Offer a very short reply. 0.86. What is the ratio of the Expenses (in $) in Namibia in 2002 to that in 2006?
Keep it short and to the point. 0.78. What is the ratio of the Expenses (in $) of St. Kitts and Nevis in 2002 to that in 2006?
Your answer should be very brief. 0.68. What is the ratio of the Expenses (in $) in Trinidad and Tobago in 2002 to that in 2006?
Offer a very short reply. 0.41. What is the ratio of the Expenses (in $) in Italy in 2002 to that in 2007?
Your answer should be very brief. 0.84. What is the ratio of the Expenses (in $) in Namibia in 2002 to that in 2007?
Provide a succinct answer. 0.68. What is the ratio of the Expenses (in $) of St. Kitts and Nevis in 2002 to that in 2007?
Provide a short and direct response. 0.65. What is the ratio of the Expenses (in $) in Trinidad and Tobago in 2002 to that in 2007?
Offer a terse response. 0.42. What is the ratio of the Expenses (in $) in Italy in 2002 to that in 2008?
Offer a very short reply. 0.81. What is the ratio of the Expenses (in $) of Namibia in 2002 to that in 2008?
Your answer should be very brief. 0.57. What is the ratio of the Expenses (in $) of St. Kitts and Nevis in 2002 to that in 2008?
Provide a succinct answer. 0.6. What is the ratio of the Expenses (in $) of Trinidad and Tobago in 2002 to that in 2008?
Your answer should be compact. 0.3. What is the ratio of the Expenses (in $) of Italy in 2003 to that in 2004?
Ensure brevity in your answer.  0.98. What is the ratio of the Expenses (in $) of Namibia in 2003 to that in 2004?
Provide a succinct answer. 0.98. What is the ratio of the Expenses (in $) of St. Kitts and Nevis in 2003 to that in 2004?
Give a very brief answer. 0.87. What is the ratio of the Expenses (in $) of Trinidad and Tobago in 2003 to that in 2004?
Give a very brief answer. 0.83. What is the ratio of the Expenses (in $) of Italy in 2003 to that in 2005?
Offer a terse response. 0.94. What is the ratio of the Expenses (in $) in Namibia in 2003 to that in 2005?
Keep it short and to the point. 0.94. What is the ratio of the Expenses (in $) in St. Kitts and Nevis in 2003 to that in 2005?
Your response must be concise. 0.76. What is the ratio of the Expenses (in $) in Trinidad and Tobago in 2003 to that in 2005?
Make the answer very short. 0.69. What is the ratio of the Expenses (in $) of Italy in 2003 to that in 2006?
Your answer should be compact. 0.9. What is the ratio of the Expenses (in $) of Namibia in 2003 to that in 2006?
Make the answer very short. 0.84. What is the ratio of the Expenses (in $) in St. Kitts and Nevis in 2003 to that in 2006?
Your response must be concise. 0.7. What is the ratio of the Expenses (in $) of Trinidad and Tobago in 2003 to that in 2006?
Ensure brevity in your answer.  0.46. What is the ratio of the Expenses (in $) in Italy in 2003 to that in 2007?
Keep it short and to the point. 0.87. What is the ratio of the Expenses (in $) in Namibia in 2003 to that in 2007?
Keep it short and to the point. 0.74. What is the ratio of the Expenses (in $) in St. Kitts and Nevis in 2003 to that in 2007?
Provide a short and direct response. 0.67. What is the ratio of the Expenses (in $) of Trinidad and Tobago in 2003 to that in 2007?
Your response must be concise. 0.47. What is the ratio of the Expenses (in $) of Italy in 2003 to that in 2008?
Keep it short and to the point. 0.84. What is the ratio of the Expenses (in $) in Namibia in 2003 to that in 2008?
Ensure brevity in your answer.  0.61. What is the ratio of the Expenses (in $) of St. Kitts and Nevis in 2003 to that in 2008?
Provide a succinct answer. 0.62. What is the ratio of the Expenses (in $) in Trinidad and Tobago in 2003 to that in 2008?
Offer a terse response. 0.34. What is the ratio of the Expenses (in $) of Italy in 2004 to that in 2005?
Ensure brevity in your answer.  0.96. What is the ratio of the Expenses (in $) in Namibia in 2004 to that in 2005?
Your answer should be very brief. 0.95. What is the ratio of the Expenses (in $) of St. Kitts and Nevis in 2004 to that in 2005?
Provide a succinct answer. 0.87. What is the ratio of the Expenses (in $) of Trinidad and Tobago in 2004 to that in 2005?
Provide a succinct answer. 0.83. What is the ratio of the Expenses (in $) in Italy in 2004 to that in 2006?
Keep it short and to the point. 0.91. What is the ratio of the Expenses (in $) in Namibia in 2004 to that in 2006?
Your answer should be very brief. 0.86. What is the ratio of the Expenses (in $) of St. Kitts and Nevis in 2004 to that in 2006?
Offer a very short reply. 0.8. What is the ratio of the Expenses (in $) of Trinidad and Tobago in 2004 to that in 2006?
Make the answer very short. 0.55. What is the ratio of the Expenses (in $) of Italy in 2004 to that in 2007?
Ensure brevity in your answer.  0.89. What is the ratio of the Expenses (in $) of Namibia in 2004 to that in 2007?
Make the answer very short. 0.76. What is the ratio of the Expenses (in $) of St. Kitts and Nevis in 2004 to that in 2007?
Offer a terse response. 0.76. What is the ratio of the Expenses (in $) of Trinidad and Tobago in 2004 to that in 2007?
Provide a succinct answer. 0.56. What is the ratio of the Expenses (in $) in Italy in 2004 to that in 2008?
Your answer should be compact. 0.85. What is the ratio of the Expenses (in $) of Namibia in 2004 to that in 2008?
Your answer should be compact. 0.63. What is the ratio of the Expenses (in $) of St. Kitts and Nevis in 2004 to that in 2008?
Offer a very short reply. 0.71. What is the ratio of the Expenses (in $) in Trinidad and Tobago in 2004 to that in 2008?
Your answer should be compact. 0.41. What is the ratio of the Expenses (in $) of Italy in 2005 to that in 2006?
Keep it short and to the point. 0.95. What is the ratio of the Expenses (in $) of Namibia in 2005 to that in 2006?
Provide a short and direct response. 0.9. What is the ratio of the Expenses (in $) in St. Kitts and Nevis in 2005 to that in 2006?
Your response must be concise. 0.92. What is the ratio of the Expenses (in $) of Trinidad and Tobago in 2005 to that in 2006?
Your answer should be compact. 0.67. What is the ratio of the Expenses (in $) in Italy in 2005 to that in 2007?
Your response must be concise. 0.93. What is the ratio of the Expenses (in $) in Namibia in 2005 to that in 2007?
Your answer should be compact. 0.79. What is the ratio of the Expenses (in $) in St. Kitts and Nevis in 2005 to that in 2007?
Provide a succinct answer. 0.88. What is the ratio of the Expenses (in $) in Trinidad and Tobago in 2005 to that in 2007?
Ensure brevity in your answer.  0.68. What is the ratio of the Expenses (in $) in Italy in 2005 to that in 2008?
Provide a succinct answer. 0.89. What is the ratio of the Expenses (in $) of Namibia in 2005 to that in 2008?
Provide a short and direct response. 0.66. What is the ratio of the Expenses (in $) of St. Kitts and Nevis in 2005 to that in 2008?
Your response must be concise. 0.82. What is the ratio of the Expenses (in $) in Trinidad and Tobago in 2005 to that in 2008?
Keep it short and to the point. 0.49. What is the ratio of the Expenses (in $) in Italy in 2006 to that in 2007?
Give a very brief answer. 0.97. What is the ratio of the Expenses (in $) of Namibia in 2006 to that in 2007?
Ensure brevity in your answer.  0.88. What is the ratio of the Expenses (in $) in St. Kitts and Nevis in 2006 to that in 2007?
Give a very brief answer. 0.96. What is the ratio of the Expenses (in $) in Trinidad and Tobago in 2006 to that in 2007?
Provide a short and direct response. 1.02. What is the ratio of the Expenses (in $) of Italy in 2006 to that in 2008?
Offer a terse response. 0.93. What is the ratio of the Expenses (in $) in Namibia in 2006 to that in 2008?
Give a very brief answer. 0.73. What is the ratio of the Expenses (in $) in St. Kitts and Nevis in 2006 to that in 2008?
Your response must be concise. 0.89. What is the ratio of the Expenses (in $) in Trinidad and Tobago in 2006 to that in 2008?
Offer a very short reply. 0.74. What is the ratio of the Expenses (in $) of Italy in 2007 to that in 2008?
Your answer should be very brief. 0.96. What is the ratio of the Expenses (in $) of Namibia in 2007 to that in 2008?
Provide a succinct answer. 0.83. What is the ratio of the Expenses (in $) in St. Kitts and Nevis in 2007 to that in 2008?
Your answer should be very brief. 0.93. What is the ratio of the Expenses (in $) in Trinidad and Tobago in 2007 to that in 2008?
Offer a very short reply. 0.72. What is the difference between the highest and the second highest Expenses (in $) of Italy?
Offer a very short reply. 2.44e+1. What is the difference between the highest and the second highest Expenses (in $) of Namibia?
Make the answer very short. 3.08e+09. What is the difference between the highest and the second highest Expenses (in $) of St. Kitts and Nevis?
Make the answer very short. 3.61e+07. What is the difference between the highest and the second highest Expenses (in $) of Trinidad and Tobago?
Provide a succinct answer. 1.21e+1. What is the difference between the highest and the lowest Expenses (in $) in Italy?
Your response must be concise. 1.31e+11. What is the difference between the highest and the lowest Expenses (in $) of Namibia?
Provide a short and direct response. 8.82e+09. What is the difference between the highest and the lowest Expenses (in $) in St. Kitts and Nevis?
Your answer should be compact. 2.29e+08. What is the difference between the highest and the lowest Expenses (in $) in Trinidad and Tobago?
Keep it short and to the point. 3.32e+1. 